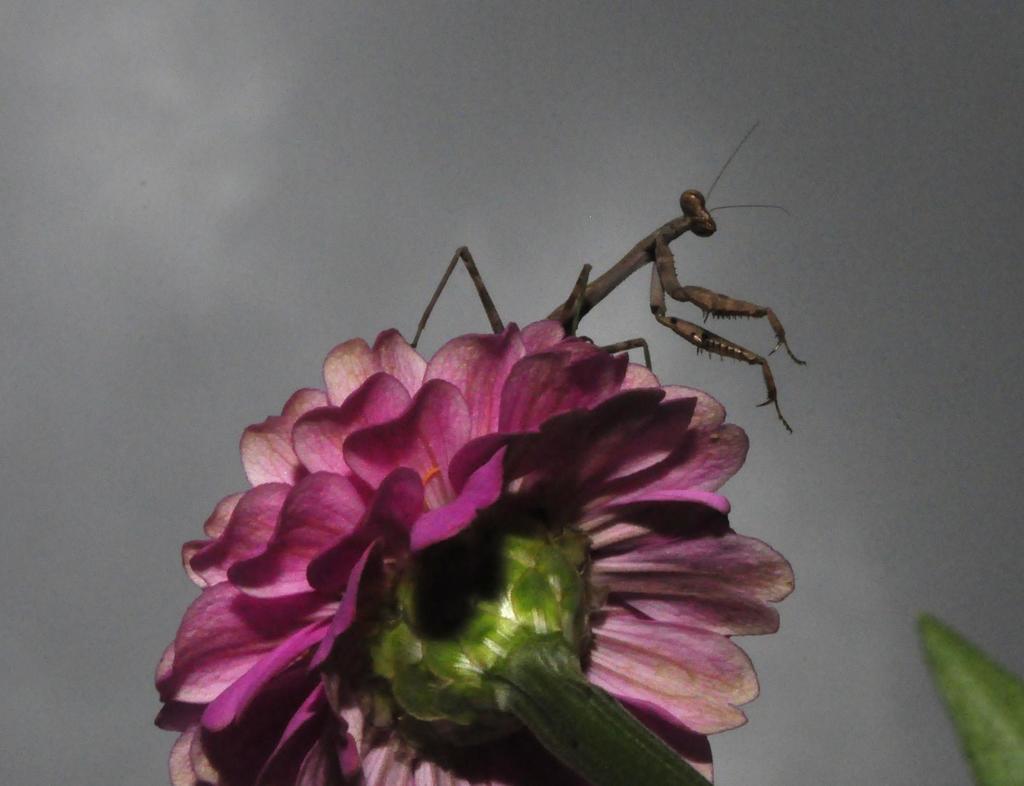Describe this image in one or two sentences. In this image we can see a flower. On the flower there is an insect. In the background it is sky. 